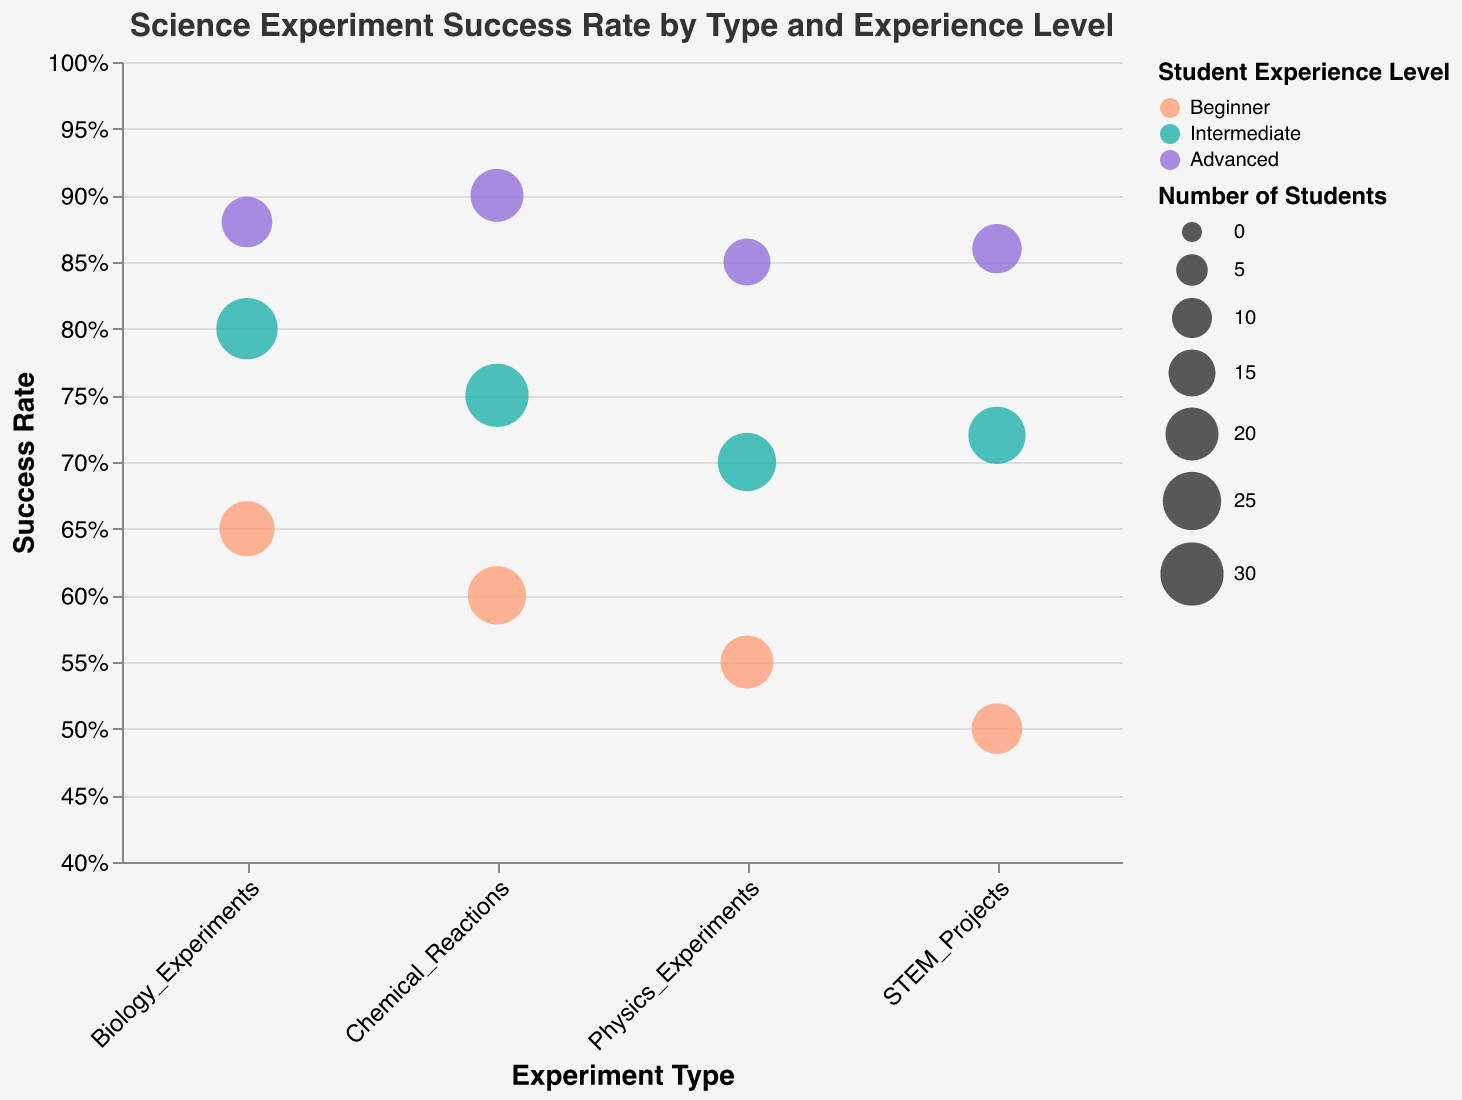What's the range of success rates for Beginner level students? The Beginner level success rates range from the lowest, which is the STEM Projects at 50%, to the highest, which is Biology Experiments at 65%.
Answer: 50% - 65% Which experiment type has the highest success rate for Advanced students? Look at the Advanced student level data points and identify the success rates. The highest is Chemical Reactions with a 90% success rate.
Answer: Chemical Reactions What is the success rate difference between Beginner and Advanced students for Physics Experiments? The success rate for Beginner students in Physics Experiments is 55%, and for Advanced students, it is 85%. The difference is 85% - 55% = 30%.
Answer: 30% How many students participated in Chemical Reactions experiments at the Intermediate level? Looking at the data points for Chemical Reactions and Intermediate level, the number of students is 30.
Answer: 30 Which group has the smallest bubble size on the chart, and what does it indicate? The smallest bubble size corresponds to Physics Experiments, Advanced level, with 15 students. Smaller bubble size indicates fewer students.
Answer: Physics Experiments, Advanced level Among all experiment types, which one shows the least variation in success rates across experience levels? We calculate the range (difference between highest and lowest success rate) for each experiment type. Biology Experiments vary from 65% to 88% (23% variation), Chemical Reactions vary from 60% to 90% (30% variation), Physics Experiments vary from 55% to 85% (30% variation), and STEM Projects vary from 50% to 86% (36% variation). The least variation is in Biology Experiments with a 23% difference.
Answer: Biology Experiments What is the average success rate for Intermediate students across all experiment types? Add the success rates for Intermediate students and divide by the number of experiment types. (75% + 70% + 80% + 72%) / 4 = 74.25%.
Answer: 74.25% How does the success rate for Intermediate students in STEM Projects compare to that for Advanced students in the same experiment type? The success rate for Intermediate students in STEM Projects is 72%, and for Advanced students, it is 86%. Advanced students have a higher success rate by 14%.
Answer: Advanced students have a higher success rate by 14% Which student experience level achieves the highest success rate in any experiment type, and what is the success rate? Look at the highest success rate in each experience level. The highest success rate overall is for Advanced students in Chemical Reactions, which is 90%.
Answer: Advanced students in Chemical Reactions, 90% What is the most common color on the chart, and what does it represent? The most common color is #20B2AA, which represents Intermediate level students as it appears in multiple experiment bubbles.
Answer: #20B2AA representing Intermediate level 